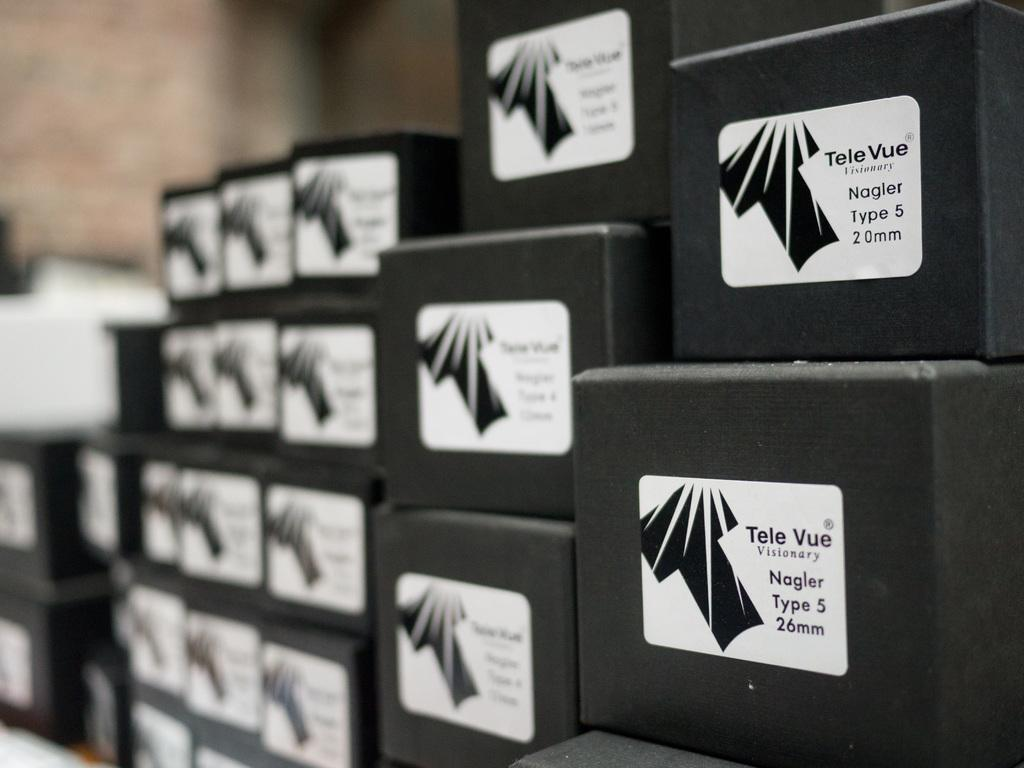<image>
Create a compact narrative representing the image presented. Several boxes are stacked of different mm of Tele Vue Visionary Nagler Type 5. 